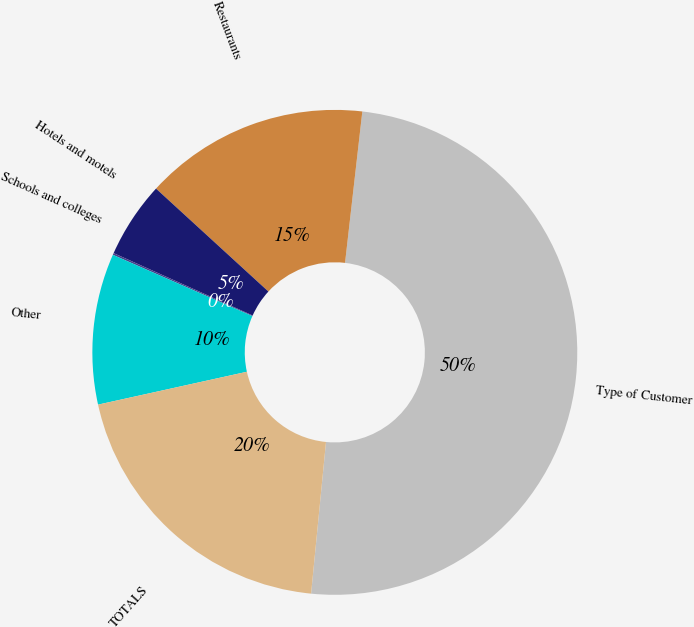Convert chart to OTSL. <chart><loc_0><loc_0><loc_500><loc_500><pie_chart><fcel>Type of Customer<fcel>Restaurants<fcel>Hotels and motels<fcel>Schools and colleges<fcel>Other<fcel>TOTALS<nl><fcel>49.75%<fcel>15.01%<fcel>5.09%<fcel>0.12%<fcel>10.05%<fcel>19.98%<nl></chart> 